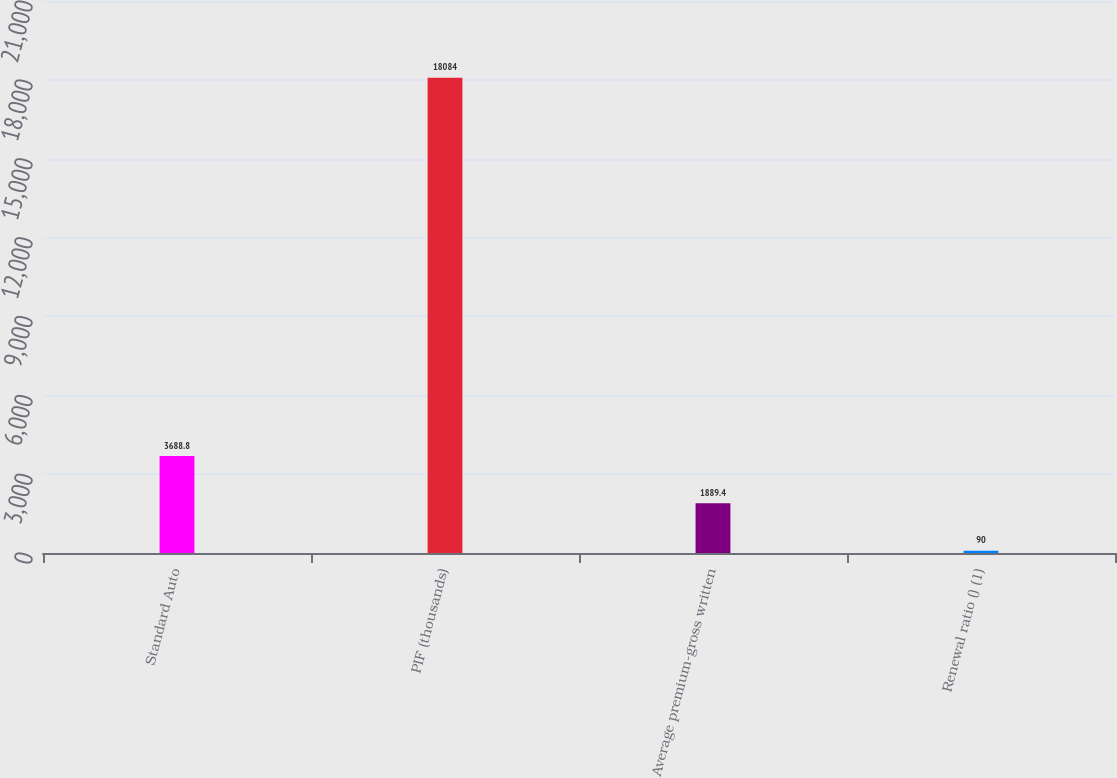Convert chart. <chart><loc_0><loc_0><loc_500><loc_500><bar_chart><fcel>Standard Auto<fcel>PIF (thousands)<fcel>Average premium-gross written<fcel>Renewal ratio () (1)<nl><fcel>3688.8<fcel>18084<fcel>1889.4<fcel>90<nl></chart> 